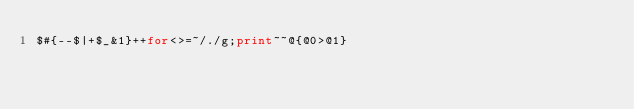<code> <loc_0><loc_0><loc_500><loc_500><_Perl_>$#{--$|+$_&1}++for<>=~/./g;print~~@{@0>@1}</code> 